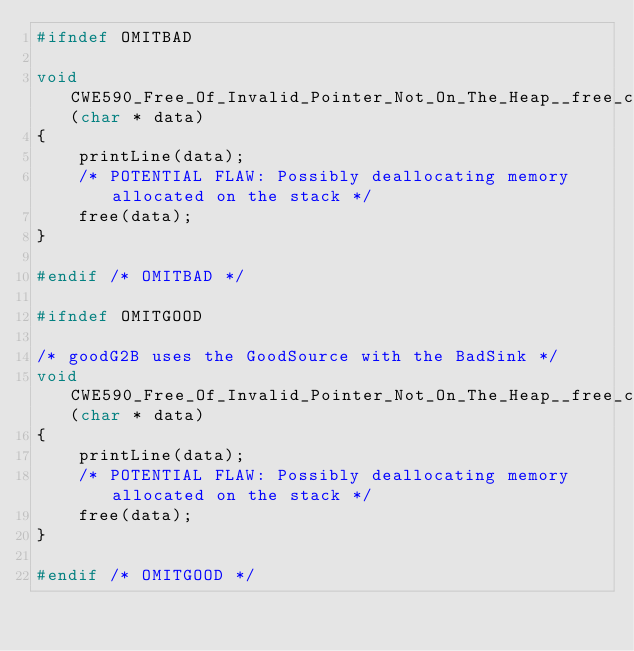<code> <loc_0><loc_0><loc_500><loc_500><_C_>#ifndef OMITBAD

void CWE590_Free_Of_Invalid_Pointer_Not_On_The_Heap__free_char_declare_53d_bad_sink(char * data)
{
    printLine(data);
    /* POTENTIAL FLAW: Possibly deallocating memory allocated on the stack */
    free(data);
}

#endif /* OMITBAD */

#ifndef OMITGOOD

/* goodG2B uses the GoodSource with the BadSink */
void CWE590_Free_Of_Invalid_Pointer_Not_On_The_Heap__free_char_declare_53d_goodG2B_sink(char * data)
{
    printLine(data);
    /* POTENTIAL FLAW: Possibly deallocating memory allocated on the stack */
    free(data);
}

#endif /* OMITGOOD */
</code> 